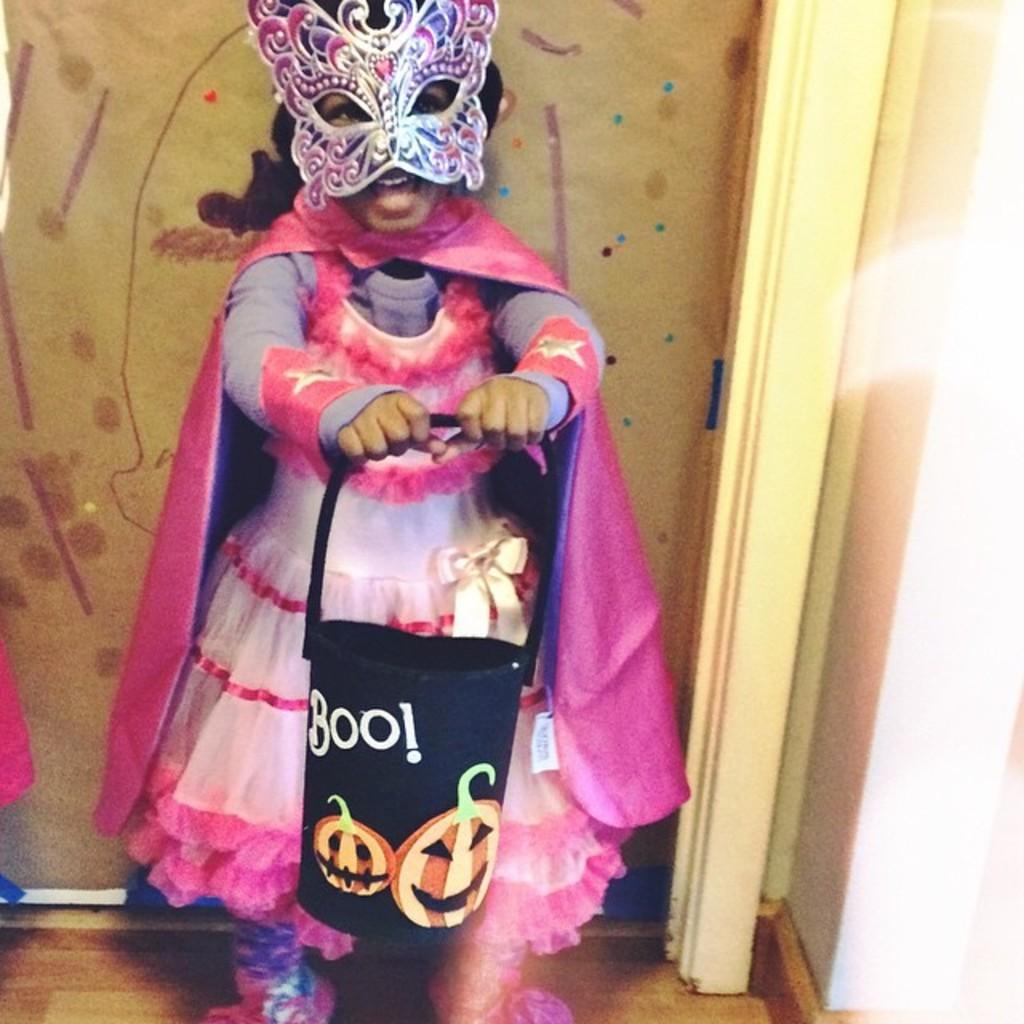How would you summarize this image in a sentence or two? In this image I can see a person wearing costume which is pink and white in color is standing and holding a black colored basket in her hand. In the background I can see the brown colored surface. 